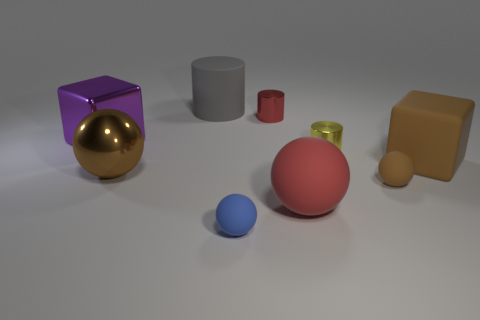There is a block that is in front of the yellow cylinder; is its size the same as the brown object that is on the left side of the tiny red thing?
Your response must be concise. Yes. Are there more big blocks that are left of the big brown matte object than matte cubes that are to the left of the large metal ball?
Ensure brevity in your answer.  Yes. What number of other objects are the same color as the big shiny sphere?
Your answer should be very brief. 2. There is a large rubber sphere; does it have the same color as the metallic cylinder behind the yellow metal object?
Your answer should be very brief. Yes. How many matte balls are to the right of the cube that is on the right side of the gray matte object?
Keep it short and to the point. 0. The big block on the left side of the large matte object behind the brown thing behind the brown metal sphere is made of what material?
Your response must be concise. Metal. There is a large thing that is both left of the big gray thing and behind the brown metal ball; what material is it made of?
Provide a succinct answer. Metal. What number of brown metal objects have the same shape as the tiny red object?
Your answer should be compact. 0. There is a rubber object that is behind the cube that is left of the large red rubber sphere; what size is it?
Ensure brevity in your answer.  Large. Do the big sphere to the right of the blue sphere and the large metal object that is in front of the shiny block have the same color?
Your response must be concise. No. 